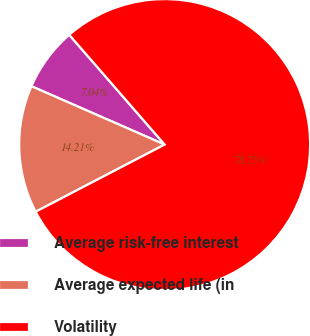<chart> <loc_0><loc_0><loc_500><loc_500><pie_chart><fcel>Average risk-free interest<fcel>Average expected life (in<fcel>Volatility<nl><fcel>7.04%<fcel>14.21%<fcel>78.74%<nl></chart> 